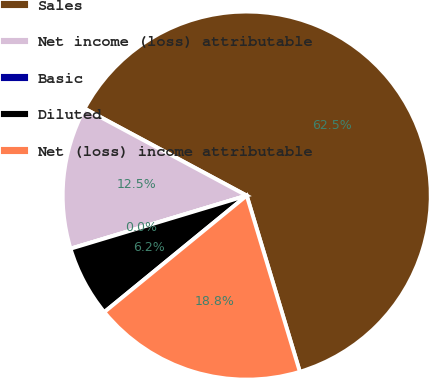Convert chart to OTSL. <chart><loc_0><loc_0><loc_500><loc_500><pie_chart><fcel>Sales<fcel>Net income (loss) attributable<fcel>Basic<fcel>Diluted<fcel>Net (loss) income attributable<nl><fcel>62.5%<fcel>12.5%<fcel>0.0%<fcel>6.25%<fcel>18.75%<nl></chart> 